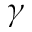<formula> <loc_0><loc_0><loc_500><loc_500>\gamma</formula> 